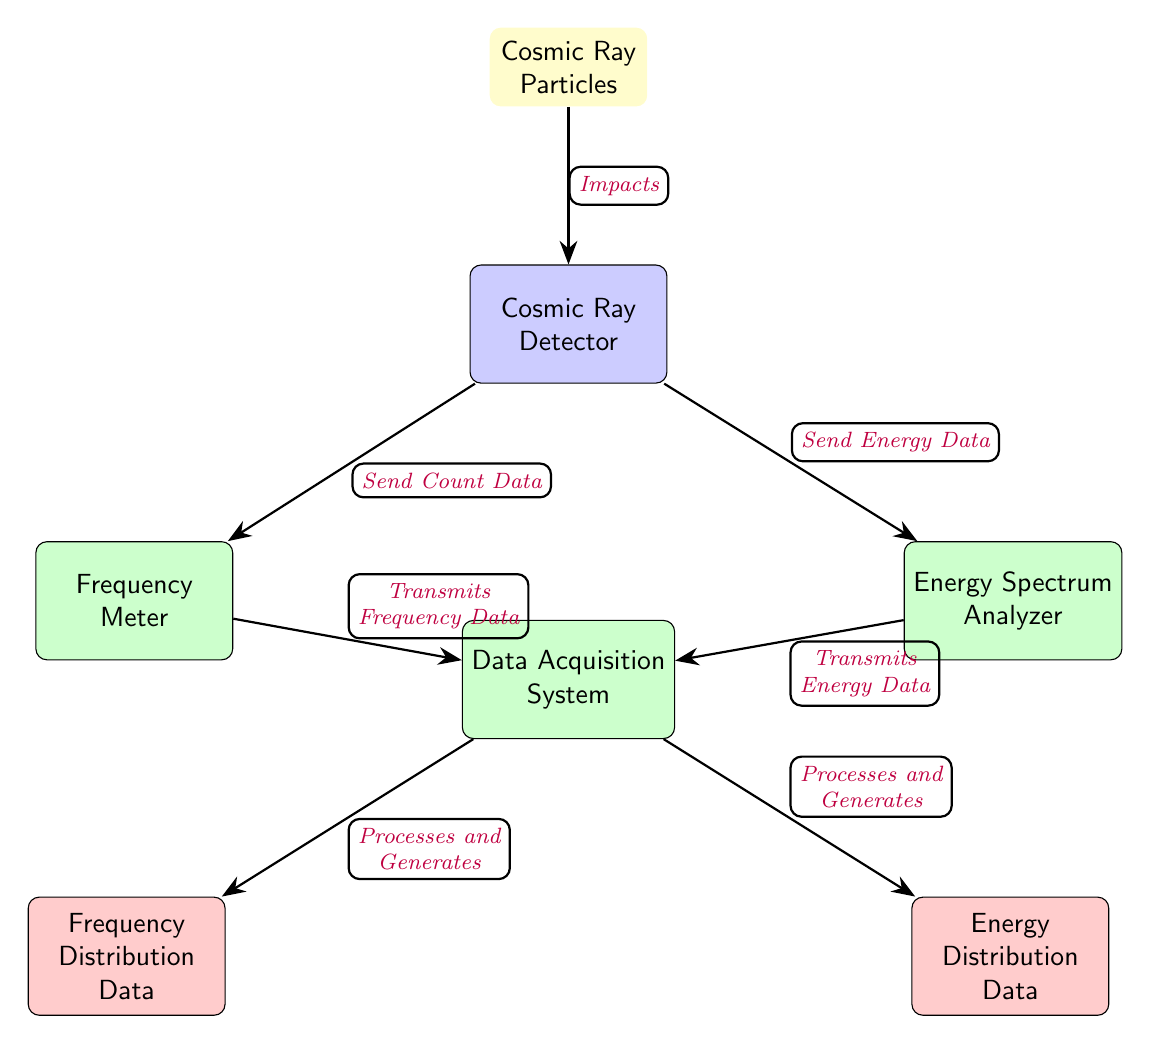What type of particles does the diagram represent? The diagram indicates that it represents "Cosmic Ray Particles" as specified in the top node.
Answer: Cosmic Ray Particles How many types of instruments are involved in the detection process? There are three instruments shown in the diagram: Frequency Meter, Energy Spectrum Analyzer, and Data Acquisition System.
Answer: Three What is the output of the Frequency Meter? The Frequency Meter transmits "Frequency Data" to the Data Acquisition System, as shown by the arrow leading to that node.
Answer: Frequency Data What data does the Energy Spectrum Analyzer transmit? The diagram shows that the Energy Spectrum Analyzer transmits "Energy Data" to the Data Acquisition System.
Answer: Energy Data What do cosmic rays do when they reach the detector? The diagram indicates that cosmic rays "Impact" the detector, which is the first action in the flow of the diagram.
Answer: Impact How does the Data Acquisition System process the signals? The Data Acquisition System generates outputs labeled as "Frequency Distribution Data" and "Energy Distribution Data," implying it processes incoming signals to produce these data types.
Answer: Processes and Generates What is the relationship between the Detector and Data Acquisition System? The Data Acquisition System receives data from the Detector, and the arrow indicates that the relationship involves the "Send Count Data" and "Send Energy Data."
Answer: Sends data What flows from the Cosmic Ray Detector to the Frequency Meter? The diagram shows that it is the "Send Count Data" that flows from the Detector to the Frequency Meter as indicated by the arrow connecting them.
Answer: Send Count Data What is the main purpose of the instruments shown in the diagram? The instruments collectively assist in measuring cosmic ray properties and analyzing the frequency and energy distribution, as inferred from their labels.
Answer: Measuring cosmic rays 